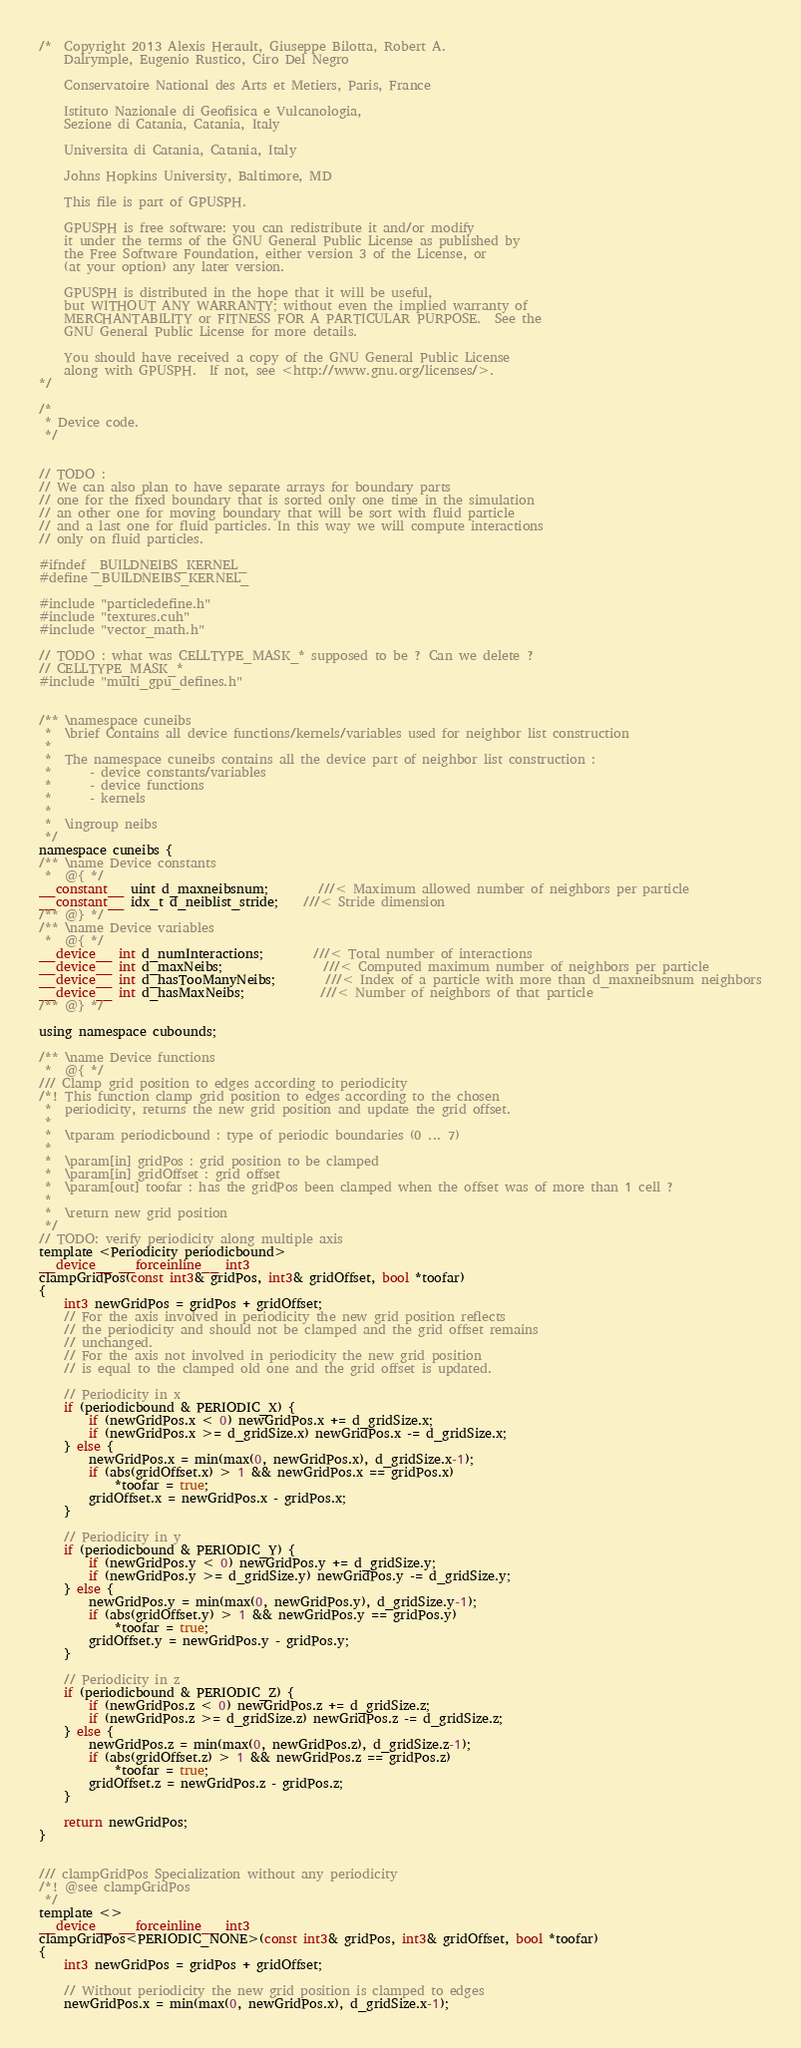<code> <loc_0><loc_0><loc_500><loc_500><_Cuda_>/*  Copyright 2013 Alexis Herault, Giuseppe Bilotta, Robert A.
 	Dalrymple, Eugenio Rustico, Ciro Del Negro

	Conservatoire National des Arts et Metiers, Paris, France

	Istituto Nazionale di Geofisica e Vulcanologia,
    Sezione di Catania, Catania, Italy

    Universita di Catania, Catania, Italy

    Johns Hopkins University, Baltimore, MD

	This file is part of GPUSPH.

    GPUSPH is free software: you can redistribute it and/or modify
    it under the terms of the GNU General Public License as published by
    the Free Software Foundation, either version 3 of the License, or
    (at your option) any later version.

    GPUSPH is distributed in the hope that it will be useful,
    but WITHOUT ANY WARRANTY; without even the implied warranty of
    MERCHANTABILITY or FITNESS FOR A PARTICULAR PURPOSE.  See the
    GNU General Public License for more details.

    You should have received a copy of the GNU General Public License
    along with GPUSPH.  If not, see <http://www.gnu.org/licenses/>.
*/

/*
 * Device code.
 */


// TODO :
// We can also plan to have separate arrays for boundary parts
// one for the fixed boundary that is sorted only one time in the simulation
// an other one for moving boundary that will be sort with fluid particle
// and a last one for fluid particles. In this way we will compute interactions
// only on fluid particles.

#ifndef _BUILDNEIBS_KERNEL_
#define _BUILDNEIBS_KERNEL_

#include "particledefine.h"
#include "textures.cuh"
#include "vector_math.h"

// TODO : what was CELLTYPE_MASK_* supposed to be ? Can we delete ?
// CELLTYPE_MASK_*
#include "multi_gpu_defines.h"


/** \namespace cuneibs
 *  \brief Contains all device functions/kernels/variables used for neighbor list construction
 *
 *  The namespace cuneibs contains all the device part of neighbor list construction :
 *  	- device constants/variables
 *  	- device functions
 *  	- kernels
 *
 *  \ingroup neibs
 */
namespace cuneibs {
/** \name Device constants
 *  @{ */
__constant__ uint d_maxneibsnum;		///< Maximum allowed number of neighbors per particle
__constant__ idx_t d_neiblist_stride;	///< Stride dimension
/** @} */
/** \name Device variables
 *  @{ */
__device__ int d_numInteractions;		///< Total number of interactions
__device__ int d_maxNeibs;				///< Computed maximum number of neighbors per particle
__device__ int d_hasTooManyNeibs;		///< Index of a particle with more than d_maxneibsnum neighbors
__device__ int d_hasMaxNeibs;			///< Number of neighbors of that particle
/** @} */

using namespace cubounds;

/** \name Device functions
 *  @{ */
/// Clamp grid position to edges according to periodicity
/*! This function clamp grid position to edges according to the chosen
 * 	periodicity, returns the new grid position and update the grid offset.
 *
 *	\tparam periodicbound : type of periodic boundaries (0 ... 7)
 *
 *	\param[in] gridPos : grid position to be clamped
 *	\param[in] gridOffset : grid offset
 *	\param[out] toofar : has the gridPos been clamped when the offset was of more than 1 cell ?
 *
 *	\return new grid position
 */
// TODO: verify periodicity along multiple axis
template <Periodicity periodicbound>
__device__ __forceinline__ int3
clampGridPos(const int3& gridPos, int3& gridOffset, bool *toofar)
{
	int3 newGridPos = gridPos + gridOffset;
	// For the axis involved in periodicity the new grid position reflects
	// the periodicity and should not be clamped and the grid offset remains
	// unchanged.
	// For the axis not involved in periodicity the new grid position
	// is equal to the clamped old one and the grid offset is updated.

	// Periodicity in x
	if (periodicbound & PERIODIC_X) {
		if (newGridPos.x < 0) newGridPos.x += d_gridSize.x;
		if (newGridPos.x >= d_gridSize.x) newGridPos.x -= d_gridSize.x;
	} else {
		newGridPos.x = min(max(0, newGridPos.x), d_gridSize.x-1);
		if (abs(gridOffset.x) > 1 && newGridPos.x == gridPos.x)
			*toofar = true;
		gridOffset.x = newGridPos.x - gridPos.x;
	}

	// Periodicity in y
	if (periodicbound & PERIODIC_Y) {
		if (newGridPos.y < 0) newGridPos.y += d_gridSize.y;
		if (newGridPos.y >= d_gridSize.y) newGridPos.y -= d_gridSize.y;
	} else {
		newGridPos.y = min(max(0, newGridPos.y), d_gridSize.y-1);
		if (abs(gridOffset.y) > 1 && newGridPos.y == gridPos.y)
			*toofar = true;
		gridOffset.y = newGridPos.y - gridPos.y;
	}

	// Periodicity in z
	if (periodicbound & PERIODIC_Z) {
		if (newGridPos.z < 0) newGridPos.z += d_gridSize.z;
		if (newGridPos.z >= d_gridSize.z) newGridPos.z -= d_gridSize.z;
	} else {
		newGridPos.z = min(max(0, newGridPos.z), d_gridSize.z-1);
		if (abs(gridOffset.z) > 1 && newGridPos.z == gridPos.z)
			*toofar = true;
		gridOffset.z = newGridPos.z - gridPos.z;
	}

	return newGridPos;
}


/// clampGridPos Specialization without any periodicity
/*! @see clampGridPos
 */
template <>
__device__ __forceinline__ int3
clampGridPos<PERIODIC_NONE>(const int3& gridPos, int3& gridOffset, bool *toofar)
{
	int3 newGridPos = gridPos + gridOffset;

	// Without periodicity the new grid position is clamped to edges
	newGridPos.x = min(max(0, newGridPos.x), d_gridSize.x-1);</code> 